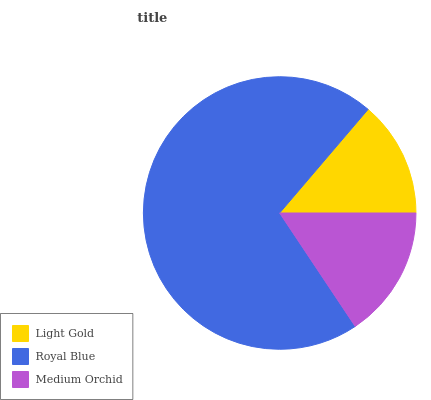Is Light Gold the minimum?
Answer yes or no. Yes. Is Royal Blue the maximum?
Answer yes or no. Yes. Is Medium Orchid the minimum?
Answer yes or no. No. Is Medium Orchid the maximum?
Answer yes or no. No. Is Royal Blue greater than Medium Orchid?
Answer yes or no. Yes. Is Medium Orchid less than Royal Blue?
Answer yes or no. Yes. Is Medium Orchid greater than Royal Blue?
Answer yes or no. No. Is Royal Blue less than Medium Orchid?
Answer yes or no. No. Is Medium Orchid the high median?
Answer yes or no. Yes. Is Medium Orchid the low median?
Answer yes or no. Yes. Is Light Gold the high median?
Answer yes or no. No. Is Light Gold the low median?
Answer yes or no. No. 